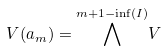Convert formula to latex. <formula><loc_0><loc_0><loc_500><loc_500>V ( \L a _ { m } ) = { \bigwedge ^ { m + 1 - \inf ( I ) } } V</formula> 